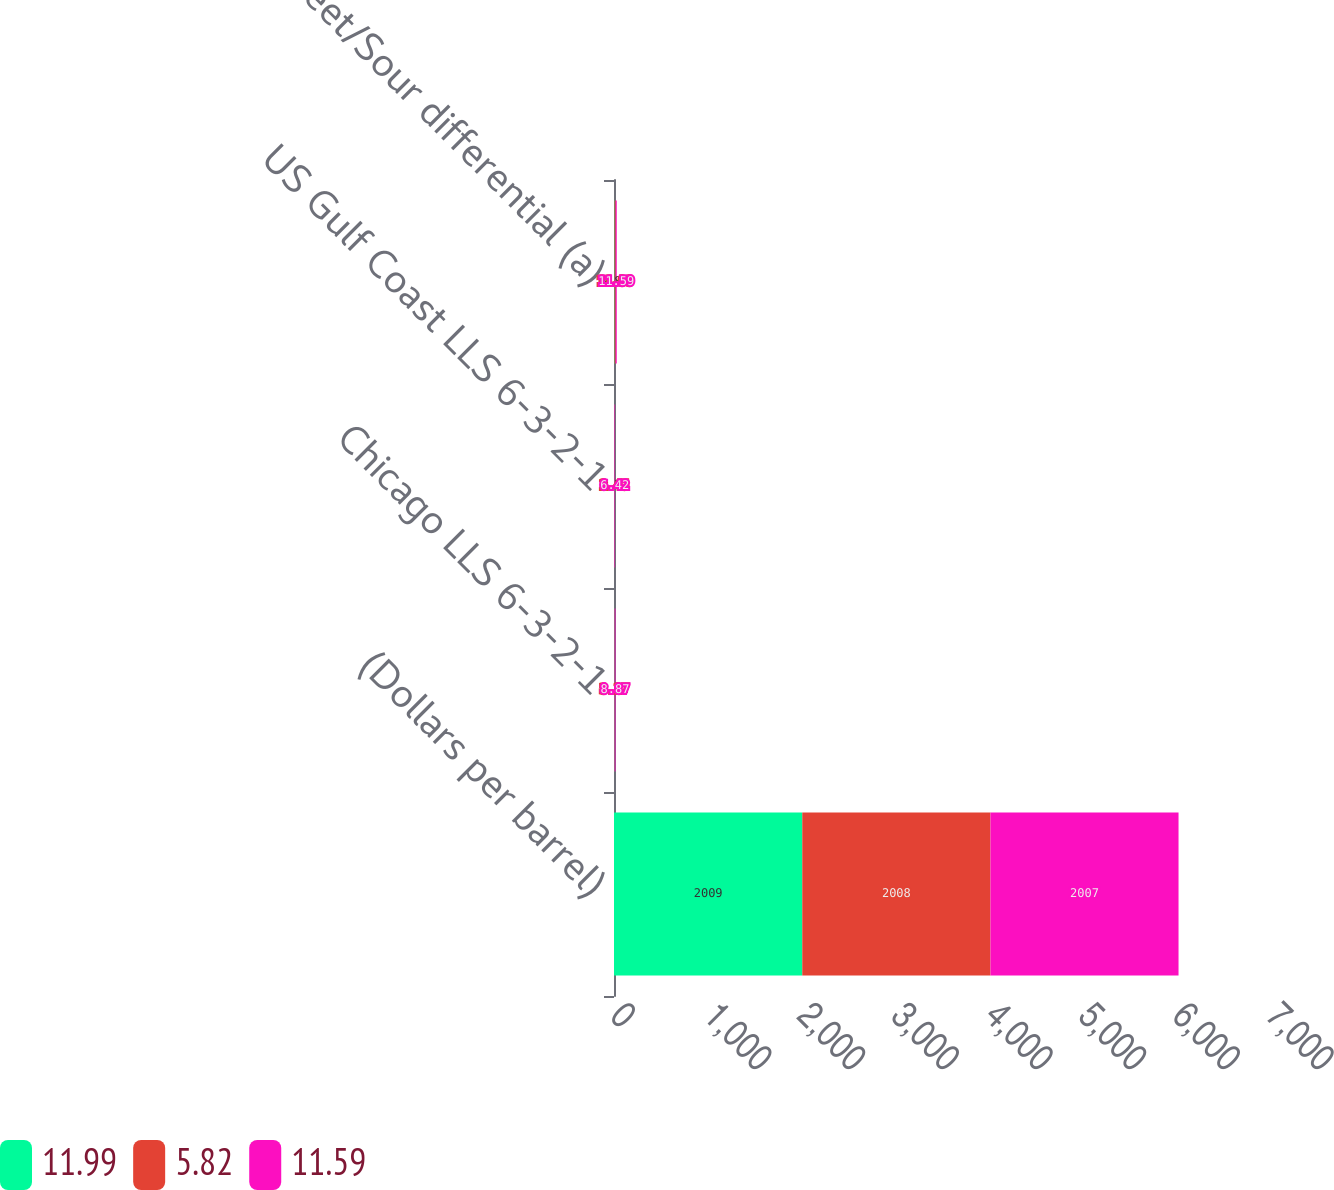Convert chart to OTSL. <chart><loc_0><loc_0><loc_500><loc_500><stacked_bar_chart><ecel><fcel>(Dollars per barrel)<fcel>Chicago LLS 6-3-2-1<fcel>US Gulf Coast LLS 6-3-2-1<fcel>Sweet/Sour differential (a)<nl><fcel>11.99<fcel>2009<fcel>3.52<fcel>2.54<fcel>5.82<nl><fcel>5.82<fcel>2008<fcel>3.27<fcel>2.45<fcel>11.99<nl><fcel>11.59<fcel>2007<fcel>8.87<fcel>6.42<fcel>11.59<nl></chart> 